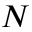Convert formula to latex. <formula><loc_0><loc_0><loc_500><loc_500>N</formula> 